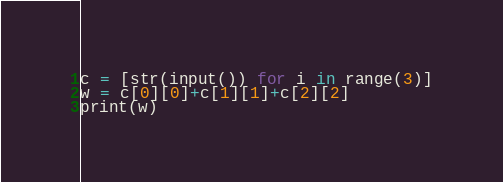Convert code to text. <code><loc_0><loc_0><loc_500><loc_500><_Python_>c = [str(input()) for i in range(3)]
w = c[0][0]+c[1][1]+c[2][2]
print(w)</code> 